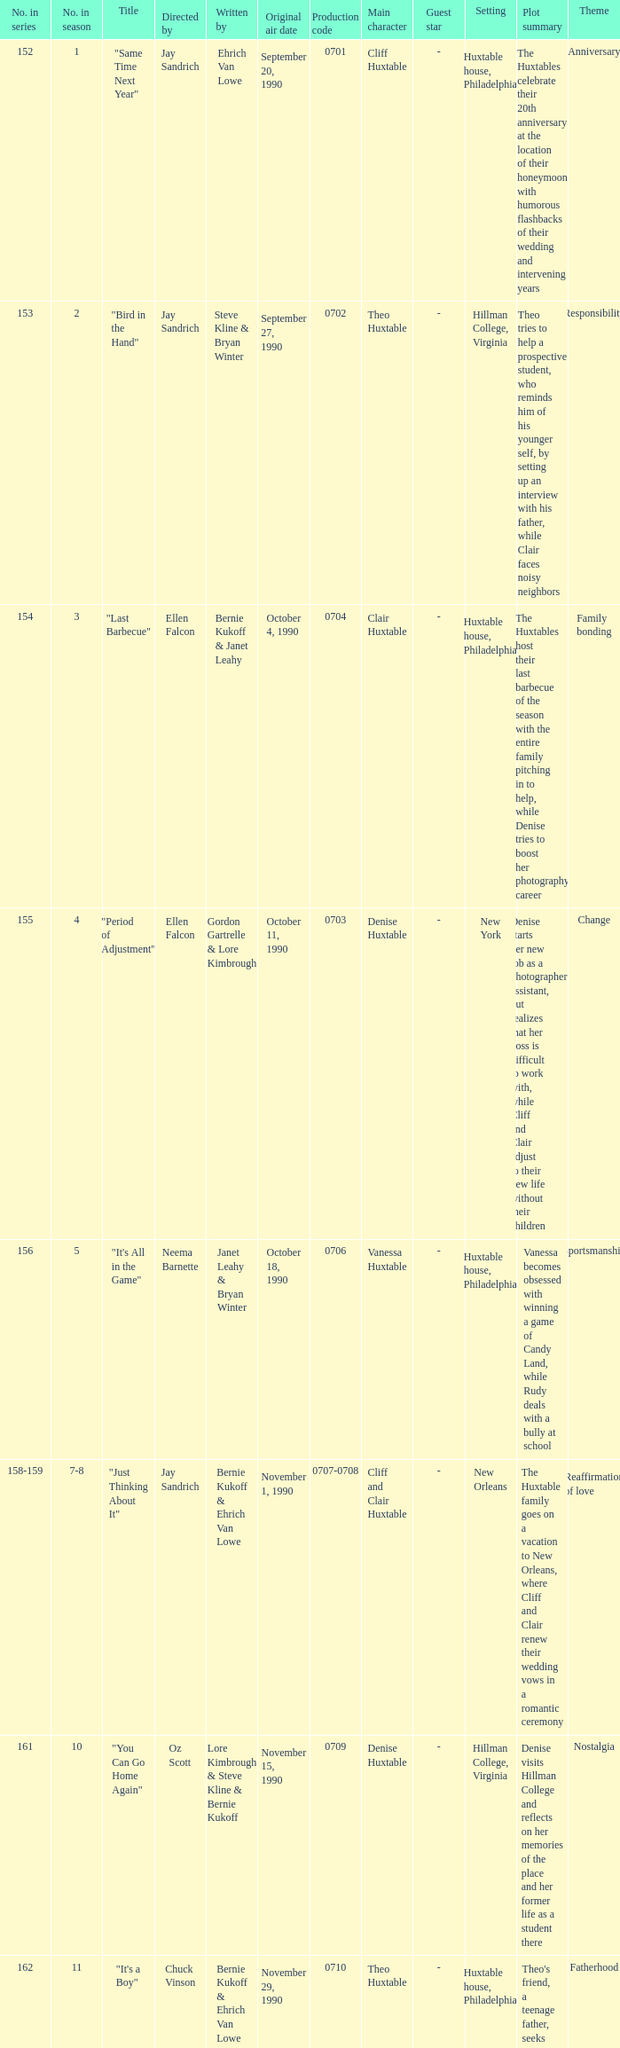Who directed the episode entitled "it's your move"? Jay Sandrich. 